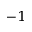<formula> <loc_0><loc_0><loc_500><loc_500>^ { - 1 }</formula> 